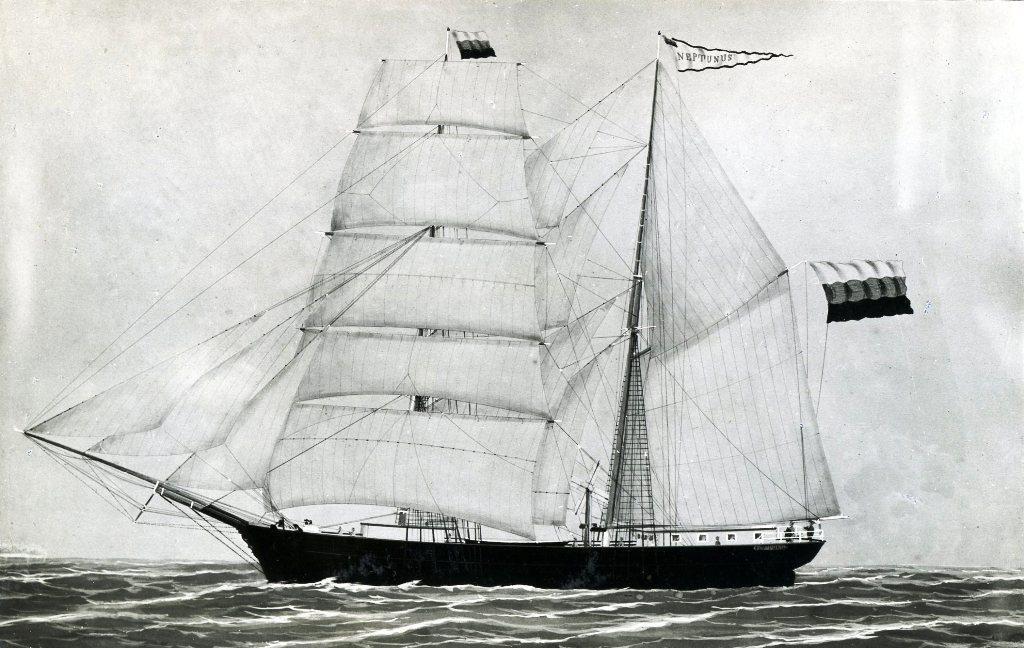Please provide a concise description of this image. Here we can see black and white image, in it we can see a ship in the water, on the ship we can see the flag. Here we can see the sky. 